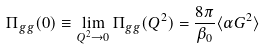<formula> <loc_0><loc_0><loc_500><loc_500>\Pi _ { g g } ( 0 ) \equiv \lim _ { Q ^ { 2 } \rightarrow 0 } \Pi _ { g g } ( Q ^ { 2 } ) = \frac { 8 \pi } { \beta _ { 0 } } \langle \alpha G ^ { 2 } \rangle</formula> 